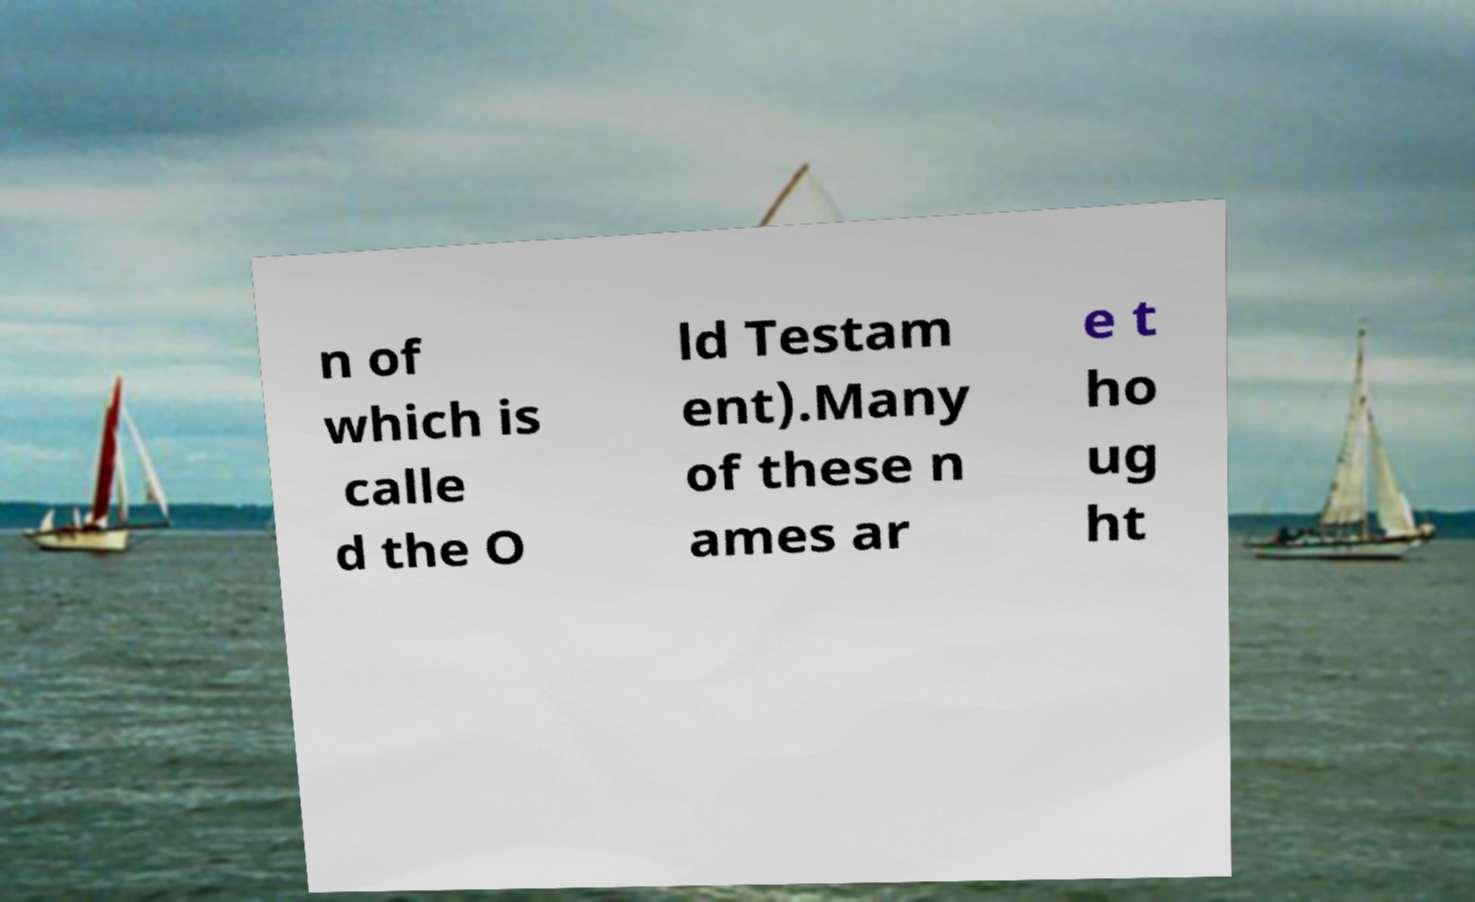Could you assist in decoding the text presented in this image and type it out clearly? n of which is calle d the O ld Testam ent).Many of these n ames ar e t ho ug ht 